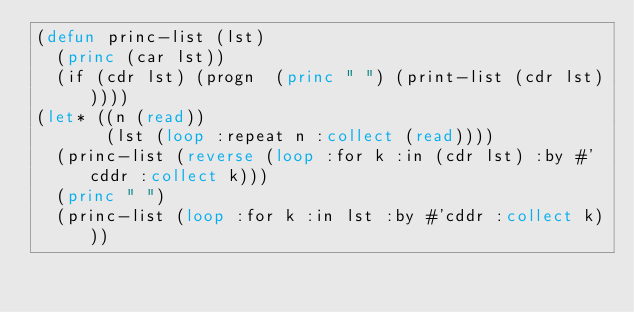Convert code to text. <code><loc_0><loc_0><loc_500><loc_500><_Lisp_>(defun princ-list (lst)
  (princ (car lst))
  (if (cdr lst) (progn  (princ " ") (print-list (cdr lst)))))
(let* ((n (read))
       (lst (loop :repeat n :collect (read))))
  (princ-list (reverse (loop :for k :in (cdr lst) :by #'cddr :collect k)))
  (princ " ")
  (princ-list (loop :for k :in lst :by #'cddr :collect k)))
</code> 